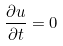<formula> <loc_0><loc_0><loc_500><loc_500>\frac { \partial u } { \partial t } = 0</formula> 